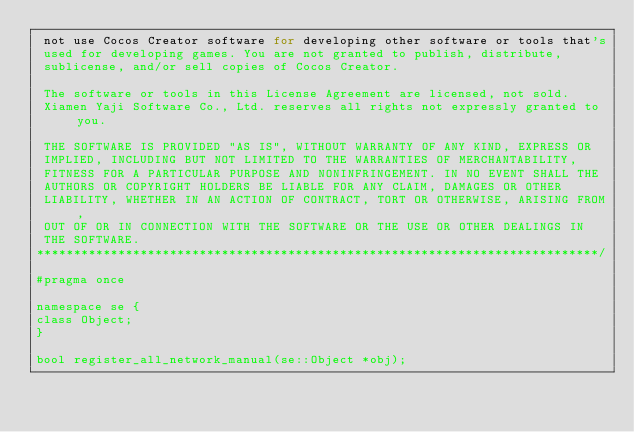<code> <loc_0><loc_0><loc_500><loc_500><_C_> not use Cocos Creator software for developing other software or tools that's
 used for developing games. You are not granted to publish, distribute,
 sublicense, and/or sell copies of Cocos Creator.

 The software or tools in this License Agreement are licensed, not sold.
 Xiamen Yaji Software Co., Ltd. reserves all rights not expressly granted to you.

 THE SOFTWARE IS PROVIDED "AS IS", WITHOUT WARRANTY OF ANY KIND, EXPRESS OR
 IMPLIED, INCLUDING BUT NOT LIMITED TO THE WARRANTIES OF MERCHANTABILITY,
 FITNESS FOR A PARTICULAR PURPOSE AND NONINFRINGEMENT. IN NO EVENT SHALL THE
 AUTHORS OR COPYRIGHT HOLDERS BE LIABLE FOR ANY CLAIM, DAMAGES OR OTHER
 LIABILITY, WHETHER IN AN ACTION OF CONTRACT, TORT OR OTHERWISE, ARISING FROM,
 OUT OF OR IN CONNECTION WITH THE SOFTWARE OR THE USE OR OTHER DEALINGS IN
 THE SOFTWARE.
****************************************************************************/

#pragma once

namespace se {
class Object;
}

bool register_all_network_manual(se::Object *obj);
</code> 